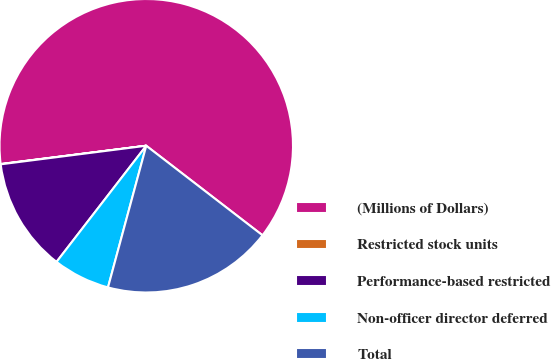<chart> <loc_0><loc_0><loc_500><loc_500><pie_chart><fcel>(Millions of Dollars)<fcel>Restricted stock units<fcel>Performance-based restricted<fcel>Non-officer director deferred<fcel>Total<nl><fcel>62.43%<fcel>0.03%<fcel>12.51%<fcel>6.27%<fcel>18.75%<nl></chart> 